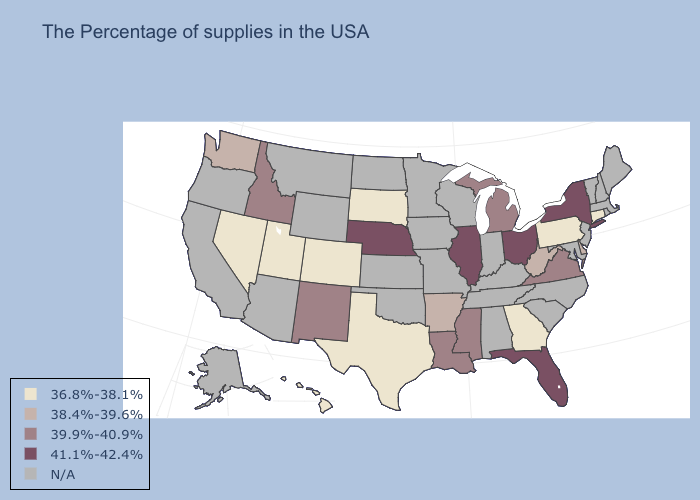What is the highest value in the West ?
Short answer required. 39.9%-40.9%. What is the value of Wisconsin?
Keep it brief. N/A. What is the lowest value in states that border Michigan?
Keep it brief. 41.1%-42.4%. Does the first symbol in the legend represent the smallest category?
Quick response, please. Yes. What is the value of Georgia?
Keep it brief. 36.8%-38.1%. What is the value of Alaska?
Short answer required. N/A. Does the first symbol in the legend represent the smallest category?
Be succinct. Yes. What is the value of Oregon?
Answer briefly. N/A. Name the states that have a value in the range 38.4%-39.6%?
Short answer required. Delaware, West Virginia, Arkansas, Washington. What is the lowest value in states that border Nebraska?
Be succinct. 36.8%-38.1%. What is the value of Ohio?
Answer briefly. 41.1%-42.4%. Name the states that have a value in the range 38.4%-39.6%?
Concise answer only. Delaware, West Virginia, Arkansas, Washington. Name the states that have a value in the range 36.8%-38.1%?
Answer briefly. Connecticut, Pennsylvania, Georgia, Texas, South Dakota, Colorado, Utah, Nevada, Hawaii. Which states have the lowest value in the USA?
Keep it brief. Connecticut, Pennsylvania, Georgia, Texas, South Dakota, Colorado, Utah, Nevada, Hawaii. 